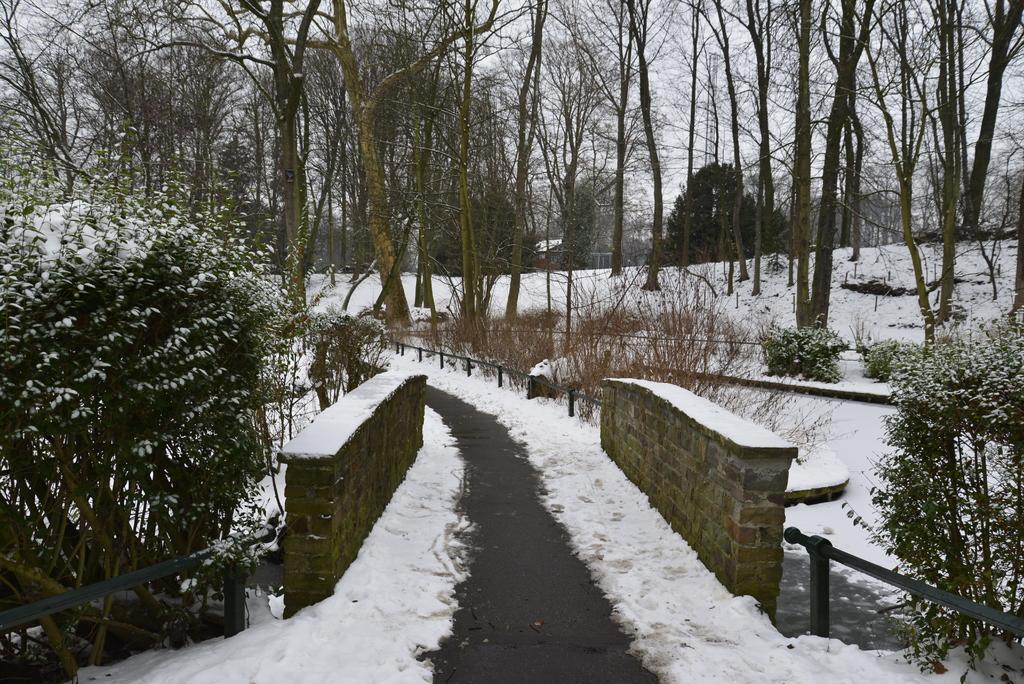Can you describe this image briefly? This looks like a pathway. I think this is a kind of a small bridge with the walls. These are the trees and bushes. This is the snow. 